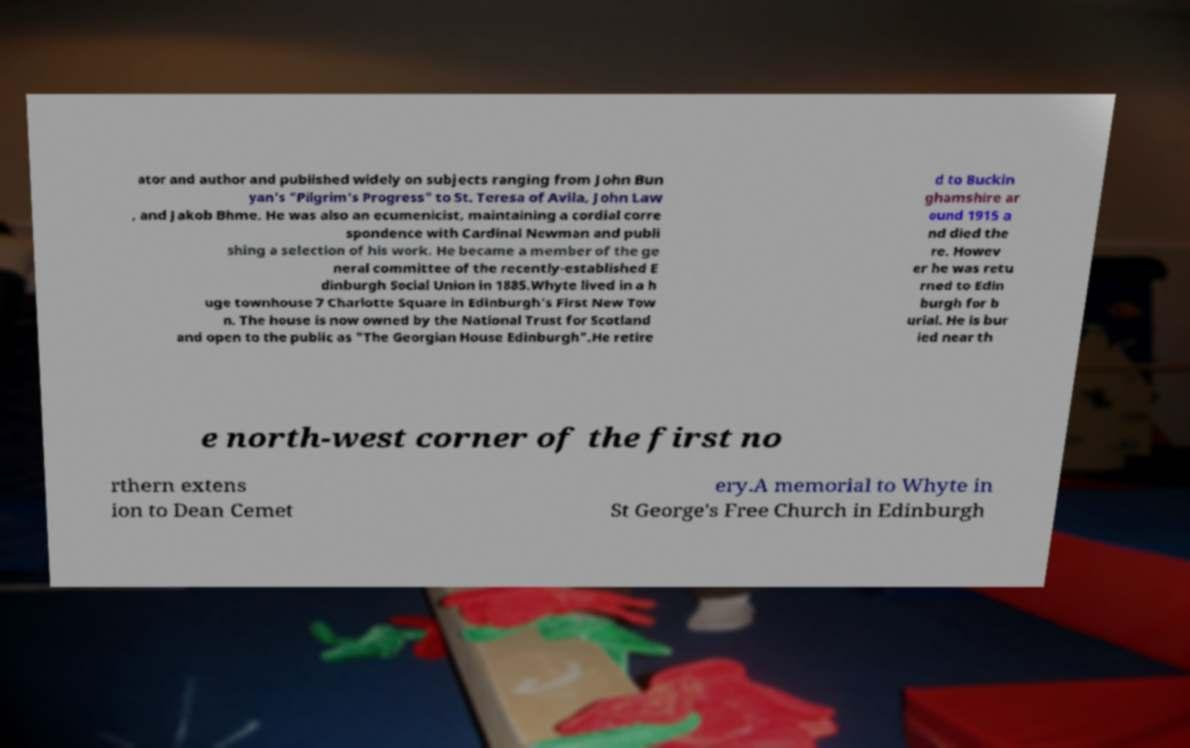What messages or text are displayed in this image? I need them in a readable, typed format. ator and author and published widely on subjects ranging from John Bun yan's "Pilgrim's Progress" to St. Teresa of Avila, John Law , and Jakob Bhme. He was also an ecumenicist, maintaining a cordial corre spondence with Cardinal Newman and publi shing a selection of his work. He became a member of the ge neral committee of the recently-established E dinburgh Social Union in 1885.Whyte lived in a h uge townhouse 7 Charlotte Square in Edinburgh's First New Tow n. The house is now owned by the National Trust for Scotland and open to the public as "The Georgian House Edinburgh".He retire d to Buckin ghamshire ar ound 1915 a nd died the re. Howev er he was retu rned to Edin burgh for b urial. He is bur ied near th e north-west corner of the first no rthern extens ion to Dean Cemet ery.A memorial to Whyte in St George's Free Church in Edinburgh 